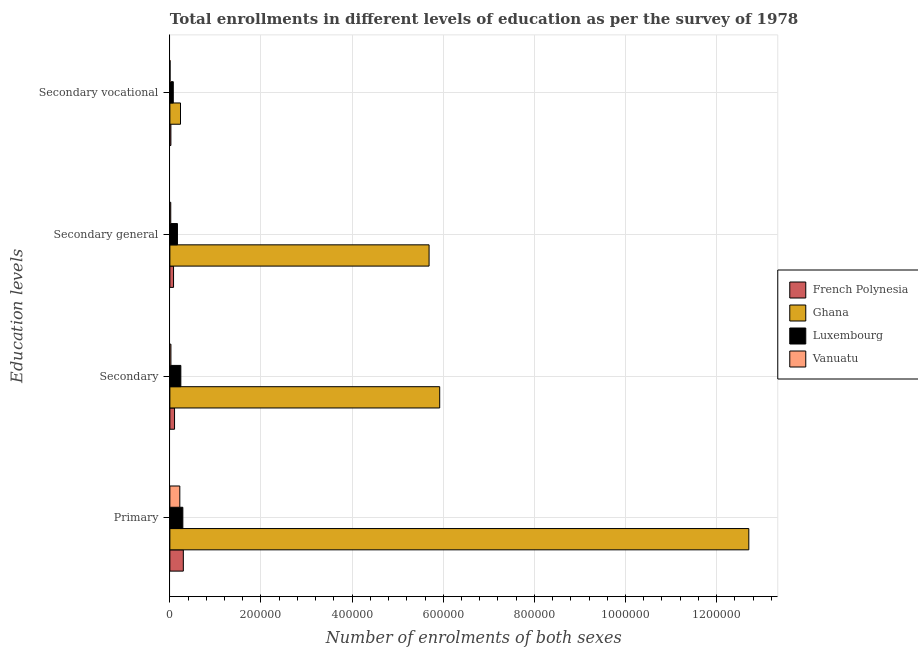Are the number of bars per tick equal to the number of legend labels?
Offer a terse response. Yes. What is the label of the 1st group of bars from the top?
Your answer should be very brief. Secondary vocational. What is the number of enrolments in primary education in French Polynesia?
Provide a succinct answer. 2.95e+04. Across all countries, what is the maximum number of enrolments in primary education?
Provide a succinct answer. 1.27e+06. Across all countries, what is the minimum number of enrolments in secondary education?
Provide a short and direct response. 2284. In which country was the number of enrolments in primary education maximum?
Your answer should be compact. Ghana. In which country was the number of enrolments in secondary general education minimum?
Your answer should be very brief. Vanuatu. What is the total number of enrolments in secondary education in the graph?
Give a very brief answer. 6.29e+05. What is the difference between the number of enrolments in secondary education in Ghana and that in Luxembourg?
Provide a succinct answer. 5.68e+05. What is the difference between the number of enrolments in secondary general education in French Polynesia and the number of enrolments in secondary education in Luxembourg?
Offer a terse response. -1.60e+04. What is the average number of enrolments in secondary vocational education per country?
Keep it short and to the point. 8340.5. What is the difference between the number of enrolments in secondary vocational education and number of enrolments in secondary education in French Polynesia?
Make the answer very short. -8047. In how many countries, is the number of enrolments in secondary general education greater than 1160000 ?
Your response must be concise. 0. What is the ratio of the number of enrolments in primary education in Luxembourg to that in French Polynesia?
Make the answer very short. 0.96. What is the difference between the highest and the second highest number of enrolments in primary education?
Keep it short and to the point. 1.24e+06. What is the difference between the highest and the lowest number of enrolments in secondary vocational education?
Make the answer very short. 2.30e+04. In how many countries, is the number of enrolments in secondary vocational education greater than the average number of enrolments in secondary vocational education taken over all countries?
Offer a very short reply. 1. What does the 4th bar from the top in Secondary vocational represents?
Your answer should be compact. French Polynesia. What does the 4th bar from the bottom in Primary represents?
Offer a very short reply. Vanuatu. How many countries are there in the graph?
Offer a very short reply. 4. Are the values on the major ticks of X-axis written in scientific E-notation?
Provide a succinct answer. No. Does the graph contain any zero values?
Give a very brief answer. No. Where does the legend appear in the graph?
Give a very brief answer. Center right. What is the title of the graph?
Provide a short and direct response. Total enrollments in different levels of education as per the survey of 1978. What is the label or title of the X-axis?
Provide a succinct answer. Number of enrolments of both sexes. What is the label or title of the Y-axis?
Offer a very short reply. Education levels. What is the Number of enrolments of both sexes in French Polynesia in Primary?
Your answer should be very brief. 2.95e+04. What is the Number of enrolments of both sexes of Ghana in Primary?
Your response must be concise. 1.27e+06. What is the Number of enrolments of both sexes in Luxembourg in Primary?
Keep it short and to the point. 2.85e+04. What is the Number of enrolments of both sexes of Vanuatu in Primary?
Provide a succinct answer. 2.18e+04. What is the Number of enrolments of both sexes in French Polynesia in Secondary?
Your response must be concise. 1.03e+04. What is the Number of enrolments of both sexes of Ghana in Secondary?
Provide a short and direct response. 5.92e+05. What is the Number of enrolments of both sexes of Luxembourg in Secondary?
Your answer should be very brief. 2.41e+04. What is the Number of enrolments of both sexes of Vanuatu in Secondary?
Make the answer very short. 2284. What is the Number of enrolments of both sexes in French Polynesia in Secondary general?
Provide a short and direct response. 8047. What is the Number of enrolments of both sexes in Ghana in Secondary general?
Offer a terse response. 5.69e+05. What is the Number of enrolments of both sexes in Luxembourg in Secondary general?
Your response must be concise. 1.66e+04. What is the Number of enrolments of both sexes in Vanuatu in Secondary general?
Keep it short and to the point. 1921. What is the Number of enrolments of both sexes in French Polynesia in Secondary vocational?
Your response must be concise. 2218. What is the Number of enrolments of both sexes in Ghana in Secondary vocational?
Ensure brevity in your answer.  2.33e+04. What is the Number of enrolments of both sexes in Luxembourg in Secondary vocational?
Offer a terse response. 7466. What is the Number of enrolments of both sexes of Vanuatu in Secondary vocational?
Make the answer very short. 363. Across all Education levels, what is the maximum Number of enrolments of both sexes in French Polynesia?
Make the answer very short. 2.95e+04. Across all Education levels, what is the maximum Number of enrolments of both sexes in Ghana?
Your response must be concise. 1.27e+06. Across all Education levels, what is the maximum Number of enrolments of both sexes of Luxembourg?
Ensure brevity in your answer.  2.85e+04. Across all Education levels, what is the maximum Number of enrolments of both sexes in Vanuatu?
Provide a succinct answer. 2.18e+04. Across all Education levels, what is the minimum Number of enrolments of both sexes in French Polynesia?
Make the answer very short. 2218. Across all Education levels, what is the minimum Number of enrolments of both sexes of Ghana?
Make the answer very short. 2.33e+04. Across all Education levels, what is the minimum Number of enrolments of both sexes of Luxembourg?
Your response must be concise. 7466. Across all Education levels, what is the minimum Number of enrolments of both sexes of Vanuatu?
Ensure brevity in your answer.  363. What is the total Number of enrolments of both sexes in French Polynesia in the graph?
Make the answer very short. 5.01e+04. What is the total Number of enrolments of both sexes of Ghana in the graph?
Keep it short and to the point. 2.46e+06. What is the total Number of enrolments of both sexes of Luxembourg in the graph?
Make the answer very short. 7.66e+04. What is the total Number of enrolments of both sexes in Vanuatu in the graph?
Provide a succinct answer. 2.64e+04. What is the difference between the Number of enrolments of both sexes in French Polynesia in Primary and that in Secondary?
Make the answer very short. 1.93e+04. What is the difference between the Number of enrolments of both sexes in Ghana in Primary and that in Secondary?
Offer a terse response. 6.79e+05. What is the difference between the Number of enrolments of both sexes of Luxembourg in Primary and that in Secondary?
Your answer should be very brief. 4409. What is the difference between the Number of enrolments of both sexes in Vanuatu in Primary and that in Secondary?
Offer a very short reply. 1.95e+04. What is the difference between the Number of enrolments of both sexes of French Polynesia in Primary and that in Secondary general?
Offer a very short reply. 2.15e+04. What is the difference between the Number of enrolments of both sexes of Ghana in Primary and that in Secondary general?
Keep it short and to the point. 7.02e+05. What is the difference between the Number of enrolments of both sexes of Luxembourg in Primary and that in Secondary general?
Keep it short and to the point. 1.19e+04. What is the difference between the Number of enrolments of both sexes of Vanuatu in Primary and that in Secondary general?
Your answer should be compact. 1.99e+04. What is the difference between the Number of enrolments of both sexes in French Polynesia in Primary and that in Secondary vocational?
Provide a short and direct response. 2.73e+04. What is the difference between the Number of enrolments of both sexes in Ghana in Primary and that in Secondary vocational?
Keep it short and to the point. 1.25e+06. What is the difference between the Number of enrolments of both sexes of Luxembourg in Primary and that in Secondary vocational?
Your response must be concise. 2.10e+04. What is the difference between the Number of enrolments of both sexes in Vanuatu in Primary and that in Secondary vocational?
Provide a short and direct response. 2.15e+04. What is the difference between the Number of enrolments of both sexes of French Polynesia in Secondary and that in Secondary general?
Provide a short and direct response. 2218. What is the difference between the Number of enrolments of both sexes in Ghana in Secondary and that in Secondary general?
Your response must be concise. 2.33e+04. What is the difference between the Number of enrolments of both sexes in Luxembourg in Secondary and that in Secondary general?
Your answer should be compact. 7466. What is the difference between the Number of enrolments of both sexes in Vanuatu in Secondary and that in Secondary general?
Your answer should be compact. 363. What is the difference between the Number of enrolments of both sexes in French Polynesia in Secondary and that in Secondary vocational?
Ensure brevity in your answer.  8047. What is the difference between the Number of enrolments of both sexes of Ghana in Secondary and that in Secondary vocational?
Provide a short and direct response. 5.69e+05. What is the difference between the Number of enrolments of both sexes in Luxembourg in Secondary and that in Secondary vocational?
Your answer should be very brief. 1.66e+04. What is the difference between the Number of enrolments of both sexes in Vanuatu in Secondary and that in Secondary vocational?
Give a very brief answer. 1921. What is the difference between the Number of enrolments of both sexes in French Polynesia in Secondary general and that in Secondary vocational?
Offer a very short reply. 5829. What is the difference between the Number of enrolments of both sexes of Ghana in Secondary general and that in Secondary vocational?
Your answer should be very brief. 5.46e+05. What is the difference between the Number of enrolments of both sexes of Luxembourg in Secondary general and that in Secondary vocational?
Give a very brief answer. 9124. What is the difference between the Number of enrolments of both sexes of Vanuatu in Secondary general and that in Secondary vocational?
Keep it short and to the point. 1558. What is the difference between the Number of enrolments of both sexes of French Polynesia in Primary and the Number of enrolments of both sexes of Ghana in Secondary?
Offer a terse response. -5.63e+05. What is the difference between the Number of enrolments of both sexes in French Polynesia in Primary and the Number of enrolments of both sexes in Luxembourg in Secondary?
Give a very brief answer. 5472. What is the difference between the Number of enrolments of both sexes of French Polynesia in Primary and the Number of enrolments of both sexes of Vanuatu in Secondary?
Make the answer very short. 2.72e+04. What is the difference between the Number of enrolments of both sexes in Ghana in Primary and the Number of enrolments of both sexes in Luxembourg in Secondary?
Keep it short and to the point. 1.25e+06. What is the difference between the Number of enrolments of both sexes in Ghana in Primary and the Number of enrolments of both sexes in Vanuatu in Secondary?
Provide a short and direct response. 1.27e+06. What is the difference between the Number of enrolments of both sexes in Luxembourg in Primary and the Number of enrolments of both sexes in Vanuatu in Secondary?
Provide a succinct answer. 2.62e+04. What is the difference between the Number of enrolments of both sexes in French Polynesia in Primary and the Number of enrolments of both sexes in Ghana in Secondary general?
Your response must be concise. -5.39e+05. What is the difference between the Number of enrolments of both sexes in French Polynesia in Primary and the Number of enrolments of both sexes in Luxembourg in Secondary general?
Your response must be concise. 1.29e+04. What is the difference between the Number of enrolments of both sexes of French Polynesia in Primary and the Number of enrolments of both sexes of Vanuatu in Secondary general?
Keep it short and to the point. 2.76e+04. What is the difference between the Number of enrolments of both sexes in Ghana in Primary and the Number of enrolments of both sexes in Luxembourg in Secondary general?
Provide a succinct answer. 1.25e+06. What is the difference between the Number of enrolments of both sexes in Ghana in Primary and the Number of enrolments of both sexes in Vanuatu in Secondary general?
Your answer should be compact. 1.27e+06. What is the difference between the Number of enrolments of both sexes in Luxembourg in Primary and the Number of enrolments of both sexes in Vanuatu in Secondary general?
Give a very brief answer. 2.65e+04. What is the difference between the Number of enrolments of both sexes in French Polynesia in Primary and the Number of enrolments of both sexes in Ghana in Secondary vocational?
Your response must be concise. 6213. What is the difference between the Number of enrolments of both sexes in French Polynesia in Primary and the Number of enrolments of both sexes in Luxembourg in Secondary vocational?
Your response must be concise. 2.21e+04. What is the difference between the Number of enrolments of both sexes of French Polynesia in Primary and the Number of enrolments of both sexes of Vanuatu in Secondary vocational?
Your answer should be very brief. 2.92e+04. What is the difference between the Number of enrolments of both sexes of Ghana in Primary and the Number of enrolments of both sexes of Luxembourg in Secondary vocational?
Provide a succinct answer. 1.26e+06. What is the difference between the Number of enrolments of both sexes in Ghana in Primary and the Number of enrolments of both sexes in Vanuatu in Secondary vocational?
Provide a succinct answer. 1.27e+06. What is the difference between the Number of enrolments of both sexes of Luxembourg in Primary and the Number of enrolments of both sexes of Vanuatu in Secondary vocational?
Your response must be concise. 2.81e+04. What is the difference between the Number of enrolments of both sexes in French Polynesia in Secondary and the Number of enrolments of both sexes in Ghana in Secondary general?
Offer a very short reply. -5.59e+05. What is the difference between the Number of enrolments of both sexes in French Polynesia in Secondary and the Number of enrolments of both sexes in Luxembourg in Secondary general?
Give a very brief answer. -6325. What is the difference between the Number of enrolments of both sexes of French Polynesia in Secondary and the Number of enrolments of both sexes of Vanuatu in Secondary general?
Make the answer very short. 8344. What is the difference between the Number of enrolments of both sexes in Ghana in Secondary and the Number of enrolments of both sexes in Luxembourg in Secondary general?
Make the answer very short. 5.76e+05. What is the difference between the Number of enrolments of both sexes in Ghana in Secondary and the Number of enrolments of both sexes in Vanuatu in Secondary general?
Offer a terse response. 5.90e+05. What is the difference between the Number of enrolments of both sexes in Luxembourg in Secondary and the Number of enrolments of both sexes in Vanuatu in Secondary general?
Your response must be concise. 2.21e+04. What is the difference between the Number of enrolments of both sexes in French Polynesia in Secondary and the Number of enrolments of both sexes in Ghana in Secondary vocational?
Keep it short and to the point. -1.30e+04. What is the difference between the Number of enrolments of both sexes of French Polynesia in Secondary and the Number of enrolments of both sexes of Luxembourg in Secondary vocational?
Provide a succinct answer. 2799. What is the difference between the Number of enrolments of both sexes of French Polynesia in Secondary and the Number of enrolments of both sexes of Vanuatu in Secondary vocational?
Provide a short and direct response. 9902. What is the difference between the Number of enrolments of both sexes in Ghana in Secondary and the Number of enrolments of both sexes in Luxembourg in Secondary vocational?
Make the answer very short. 5.85e+05. What is the difference between the Number of enrolments of both sexes of Ghana in Secondary and the Number of enrolments of both sexes of Vanuatu in Secondary vocational?
Provide a short and direct response. 5.92e+05. What is the difference between the Number of enrolments of both sexes in Luxembourg in Secondary and the Number of enrolments of both sexes in Vanuatu in Secondary vocational?
Your response must be concise. 2.37e+04. What is the difference between the Number of enrolments of both sexes of French Polynesia in Secondary general and the Number of enrolments of both sexes of Ghana in Secondary vocational?
Make the answer very short. -1.53e+04. What is the difference between the Number of enrolments of both sexes in French Polynesia in Secondary general and the Number of enrolments of both sexes in Luxembourg in Secondary vocational?
Ensure brevity in your answer.  581. What is the difference between the Number of enrolments of both sexes of French Polynesia in Secondary general and the Number of enrolments of both sexes of Vanuatu in Secondary vocational?
Ensure brevity in your answer.  7684. What is the difference between the Number of enrolments of both sexes in Ghana in Secondary general and the Number of enrolments of both sexes in Luxembourg in Secondary vocational?
Your answer should be very brief. 5.61e+05. What is the difference between the Number of enrolments of both sexes in Ghana in Secondary general and the Number of enrolments of both sexes in Vanuatu in Secondary vocational?
Your answer should be compact. 5.69e+05. What is the difference between the Number of enrolments of both sexes of Luxembourg in Secondary general and the Number of enrolments of both sexes of Vanuatu in Secondary vocational?
Ensure brevity in your answer.  1.62e+04. What is the average Number of enrolments of both sexes in French Polynesia per Education levels?
Make the answer very short. 1.25e+04. What is the average Number of enrolments of both sexes in Ghana per Education levels?
Provide a succinct answer. 6.14e+05. What is the average Number of enrolments of both sexes in Luxembourg per Education levels?
Your response must be concise. 1.91e+04. What is the average Number of enrolments of both sexes of Vanuatu per Education levels?
Make the answer very short. 6596. What is the difference between the Number of enrolments of both sexes of French Polynesia and Number of enrolments of both sexes of Ghana in Primary?
Offer a terse response. -1.24e+06. What is the difference between the Number of enrolments of both sexes of French Polynesia and Number of enrolments of both sexes of Luxembourg in Primary?
Your response must be concise. 1063. What is the difference between the Number of enrolments of both sexes in French Polynesia and Number of enrolments of both sexes in Vanuatu in Primary?
Your answer should be compact. 7712. What is the difference between the Number of enrolments of both sexes in Ghana and Number of enrolments of both sexes in Luxembourg in Primary?
Provide a succinct answer. 1.24e+06. What is the difference between the Number of enrolments of both sexes in Ghana and Number of enrolments of both sexes in Vanuatu in Primary?
Provide a short and direct response. 1.25e+06. What is the difference between the Number of enrolments of both sexes of Luxembourg and Number of enrolments of both sexes of Vanuatu in Primary?
Ensure brevity in your answer.  6649. What is the difference between the Number of enrolments of both sexes in French Polynesia and Number of enrolments of both sexes in Ghana in Secondary?
Ensure brevity in your answer.  -5.82e+05. What is the difference between the Number of enrolments of both sexes of French Polynesia and Number of enrolments of both sexes of Luxembourg in Secondary?
Keep it short and to the point. -1.38e+04. What is the difference between the Number of enrolments of both sexes of French Polynesia and Number of enrolments of both sexes of Vanuatu in Secondary?
Ensure brevity in your answer.  7981. What is the difference between the Number of enrolments of both sexes in Ghana and Number of enrolments of both sexes in Luxembourg in Secondary?
Provide a short and direct response. 5.68e+05. What is the difference between the Number of enrolments of both sexes in Ghana and Number of enrolments of both sexes in Vanuatu in Secondary?
Your response must be concise. 5.90e+05. What is the difference between the Number of enrolments of both sexes in Luxembourg and Number of enrolments of both sexes in Vanuatu in Secondary?
Provide a succinct answer. 2.18e+04. What is the difference between the Number of enrolments of both sexes in French Polynesia and Number of enrolments of both sexes in Ghana in Secondary general?
Your answer should be very brief. -5.61e+05. What is the difference between the Number of enrolments of both sexes of French Polynesia and Number of enrolments of both sexes of Luxembourg in Secondary general?
Your answer should be compact. -8543. What is the difference between the Number of enrolments of both sexes in French Polynesia and Number of enrolments of both sexes in Vanuatu in Secondary general?
Offer a very short reply. 6126. What is the difference between the Number of enrolments of both sexes of Ghana and Number of enrolments of both sexes of Luxembourg in Secondary general?
Provide a short and direct response. 5.52e+05. What is the difference between the Number of enrolments of both sexes in Ghana and Number of enrolments of both sexes in Vanuatu in Secondary general?
Ensure brevity in your answer.  5.67e+05. What is the difference between the Number of enrolments of both sexes of Luxembourg and Number of enrolments of both sexes of Vanuatu in Secondary general?
Keep it short and to the point. 1.47e+04. What is the difference between the Number of enrolments of both sexes of French Polynesia and Number of enrolments of both sexes of Ghana in Secondary vocational?
Ensure brevity in your answer.  -2.11e+04. What is the difference between the Number of enrolments of both sexes in French Polynesia and Number of enrolments of both sexes in Luxembourg in Secondary vocational?
Your answer should be very brief. -5248. What is the difference between the Number of enrolments of both sexes in French Polynesia and Number of enrolments of both sexes in Vanuatu in Secondary vocational?
Keep it short and to the point. 1855. What is the difference between the Number of enrolments of both sexes in Ghana and Number of enrolments of both sexes in Luxembourg in Secondary vocational?
Offer a very short reply. 1.58e+04. What is the difference between the Number of enrolments of both sexes in Ghana and Number of enrolments of both sexes in Vanuatu in Secondary vocational?
Your answer should be compact. 2.30e+04. What is the difference between the Number of enrolments of both sexes in Luxembourg and Number of enrolments of both sexes in Vanuatu in Secondary vocational?
Make the answer very short. 7103. What is the ratio of the Number of enrolments of both sexes in French Polynesia in Primary to that in Secondary?
Give a very brief answer. 2.88. What is the ratio of the Number of enrolments of both sexes of Ghana in Primary to that in Secondary?
Your answer should be very brief. 2.15. What is the ratio of the Number of enrolments of both sexes in Luxembourg in Primary to that in Secondary?
Ensure brevity in your answer.  1.18. What is the ratio of the Number of enrolments of both sexes in Vanuatu in Primary to that in Secondary?
Your answer should be very brief. 9.55. What is the ratio of the Number of enrolments of both sexes of French Polynesia in Primary to that in Secondary general?
Your response must be concise. 3.67. What is the ratio of the Number of enrolments of both sexes in Ghana in Primary to that in Secondary general?
Ensure brevity in your answer.  2.23. What is the ratio of the Number of enrolments of both sexes of Luxembourg in Primary to that in Secondary general?
Offer a terse response. 1.72. What is the ratio of the Number of enrolments of both sexes in Vanuatu in Primary to that in Secondary general?
Offer a terse response. 11.36. What is the ratio of the Number of enrolments of both sexes of French Polynesia in Primary to that in Secondary vocational?
Make the answer very short. 13.31. What is the ratio of the Number of enrolments of both sexes of Ghana in Primary to that in Secondary vocational?
Make the answer very short. 54.5. What is the ratio of the Number of enrolments of both sexes of Luxembourg in Primary to that in Secondary vocational?
Offer a very short reply. 3.81. What is the ratio of the Number of enrolments of both sexes in Vanuatu in Primary to that in Secondary vocational?
Offer a very short reply. 60.1. What is the ratio of the Number of enrolments of both sexes of French Polynesia in Secondary to that in Secondary general?
Your answer should be compact. 1.28. What is the ratio of the Number of enrolments of both sexes in Ghana in Secondary to that in Secondary general?
Offer a terse response. 1.04. What is the ratio of the Number of enrolments of both sexes of Luxembourg in Secondary to that in Secondary general?
Provide a succinct answer. 1.45. What is the ratio of the Number of enrolments of both sexes in Vanuatu in Secondary to that in Secondary general?
Provide a succinct answer. 1.19. What is the ratio of the Number of enrolments of both sexes in French Polynesia in Secondary to that in Secondary vocational?
Ensure brevity in your answer.  4.63. What is the ratio of the Number of enrolments of both sexes in Ghana in Secondary to that in Secondary vocational?
Your response must be concise. 25.4. What is the ratio of the Number of enrolments of both sexes in Luxembourg in Secondary to that in Secondary vocational?
Ensure brevity in your answer.  3.22. What is the ratio of the Number of enrolments of both sexes in Vanuatu in Secondary to that in Secondary vocational?
Give a very brief answer. 6.29. What is the ratio of the Number of enrolments of both sexes of French Polynesia in Secondary general to that in Secondary vocational?
Keep it short and to the point. 3.63. What is the ratio of the Number of enrolments of both sexes in Ghana in Secondary general to that in Secondary vocational?
Provide a succinct answer. 24.4. What is the ratio of the Number of enrolments of both sexes in Luxembourg in Secondary general to that in Secondary vocational?
Provide a succinct answer. 2.22. What is the ratio of the Number of enrolments of both sexes in Vanuatu in Secondary general to that in Secondary vocational?
Ensure brevity in your answer.  5.29. What is the difference between the highest and the second highest Number of enrolments of both sexes in French Polynesia?
Offer a terse response. 1.93e+04. What is the difference between the highest and the second highest Number of enrolments of both sexes of Ghana?
Your answer should be compact. 6.79e+05. What is the difference between the highest and the second highest Number of enrolments of both sexes of Luxembourg?
Give a very brief answer. 4409. What is the difference between the highest and the second highest Number of enrolments of both sexes of Vanuatu?
Make the answer very short. 1.95e+04. What is the difference between the highest and the lowest Number of enrolments of both sexes in French Polynesia?
Keep it short and to the point. 2.73e+04. What is the difference between the highest and the lowest Number of enrolments of both sexes in Ghana?
Give a very brief answer. 1.25e+06. What is the difference between the highest and the lowest Number of enrolments of both sexes in Luxembourg?
Make the answer very short. 2.10e+04. What is the difference between the highest and the lowest Number of enrolments of both sexes of Vanuatu?
Make the answer very short. 2.15e+04. 